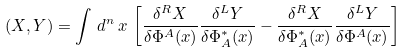Convert formula to latex. <formula><loc_0><loc_0><loc_500><loc_500>( X , Y ) = \int \, d ^ { n } \, x \, \left [ \frac { \delta ^ { R } X } { \delta \Phi ^ { A } ( x ) } \frac { \delta ^ { L } Y } { \delta \Phi ^ { * } _ { A } ( x ) } - \frac { \delta ^ { R } X } { \delta \Phi ^ { * } _ { A } ( x ) } \frac { \delta ^ { L } Y } { \delta \Phi ^ { A } ( x ) } \right ]</formula> 